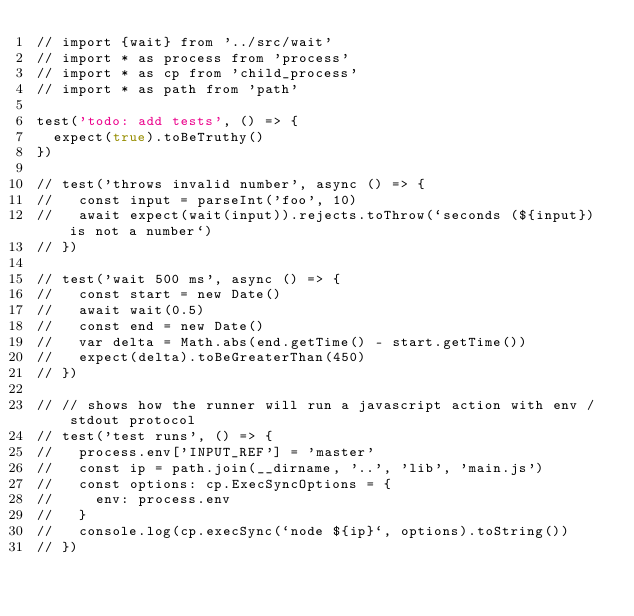<code> <loc_0><loc_0><loc_500><loc_500><_TypeScript_>// import {wait} from '../src/wait'
// import * as process from 'process'
// import * as cp from 'child_process'
// import * as path from 'path'

test('todo: add tests', () => {
  expect(true).toBeTruthy()
})

// test('throws invalid number', async () => {
//   const input = parseInt('foo', 10)
//   await expect(wait(input)).rejects.toThrow(`seconds (${input}) is not a number`)
// })

// test('wait 500 ms', async () => {
//   const start = new Date()
//   await wait(0.5)
//   const end = new Date()
//   var delta = Math.abs(end.getTime() - start.getTime())
//   expect(delta).toBeGreaterThan(450)
// })

// // shows how the runner will run a javascript action with env / stdout protocol
// test('test runs', () => {
//   process.env['INPUT_REF'] = 'master'
//   const ip = path.join(__dirname, '..', 'lib', 'main.js')
//   const options: cp.ExecSyncOptions = {
//     env: process.env
//   }
//   console.log(cp.execSync(`node ${ip}`, options).toString())
// })
</code> 